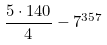Convert formula to latex. <formula><loc_0><loc_0><loc_500><loc_500>\frac { 5 \cdot 1 4 0 } { 4 } - 7 ^ { 3 5 7 }</formula> 